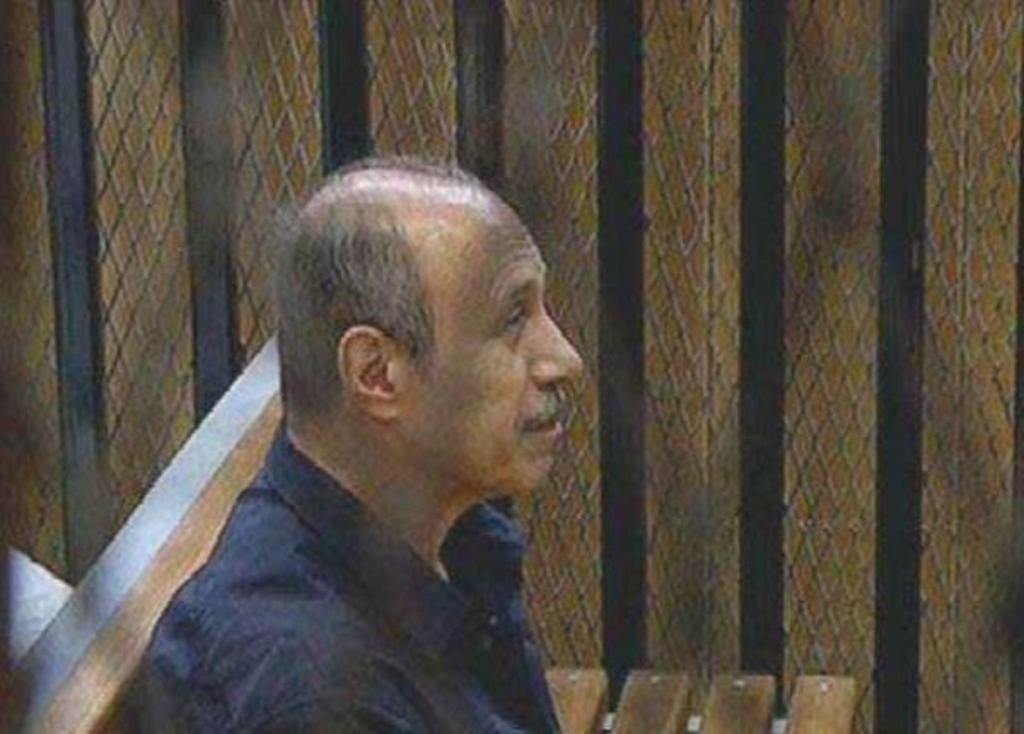What is the man in the image doing? The man is seated on a bench in the image. What can be seen on the side in the image? There is a metal fence on the side in the image. How much money is being exchanged between the man and the ship in the image? There is no ship present in the image, and no money exchange is taking place. 